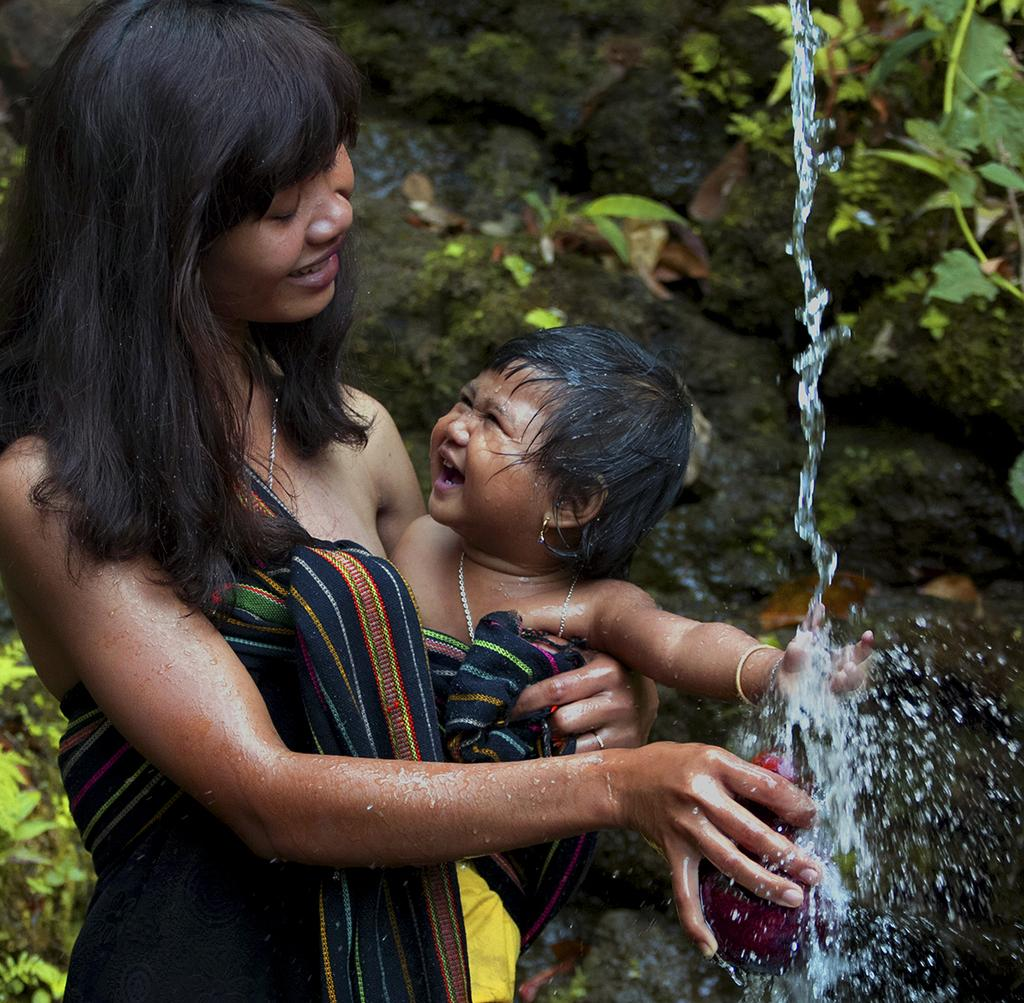What is the woman in the image doing? The woman is standing in the image and holding a baby. Can you describe the baby in the image? The baby is being held by the woman in the image. What can be seen in the background of the image? The background of the image includes leaves. What is the primary element visible in the image? Water is visible in the image. What type of crate is being used to hold the gun in the image? There is no crate or gun present in the image. 